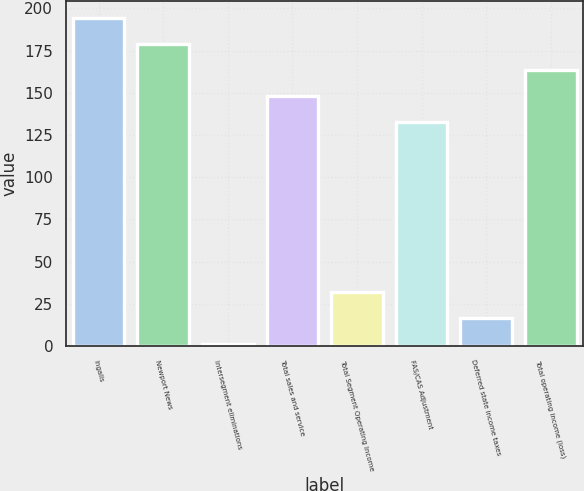Convert chart to OTSL. <chart><loc_0><loc_0><loc_500><loc_500><bar_chart><fcel>Ingalls<fcel>Newport News<fcel>Intersegment eliminations<fcel>Total sales and service<fcel>Total Segment Operating Income<fcel>FAS/CAS Adjustment<fcel>Deferred state income taxes<fcel>Total operating income (loss)<nl><fcel>194.6<fcel>179.2<fcel>1<fcel>148.4<fcel>31.8<fcel>133<fcel>16.4<fcel>163.8<nl></chart> 